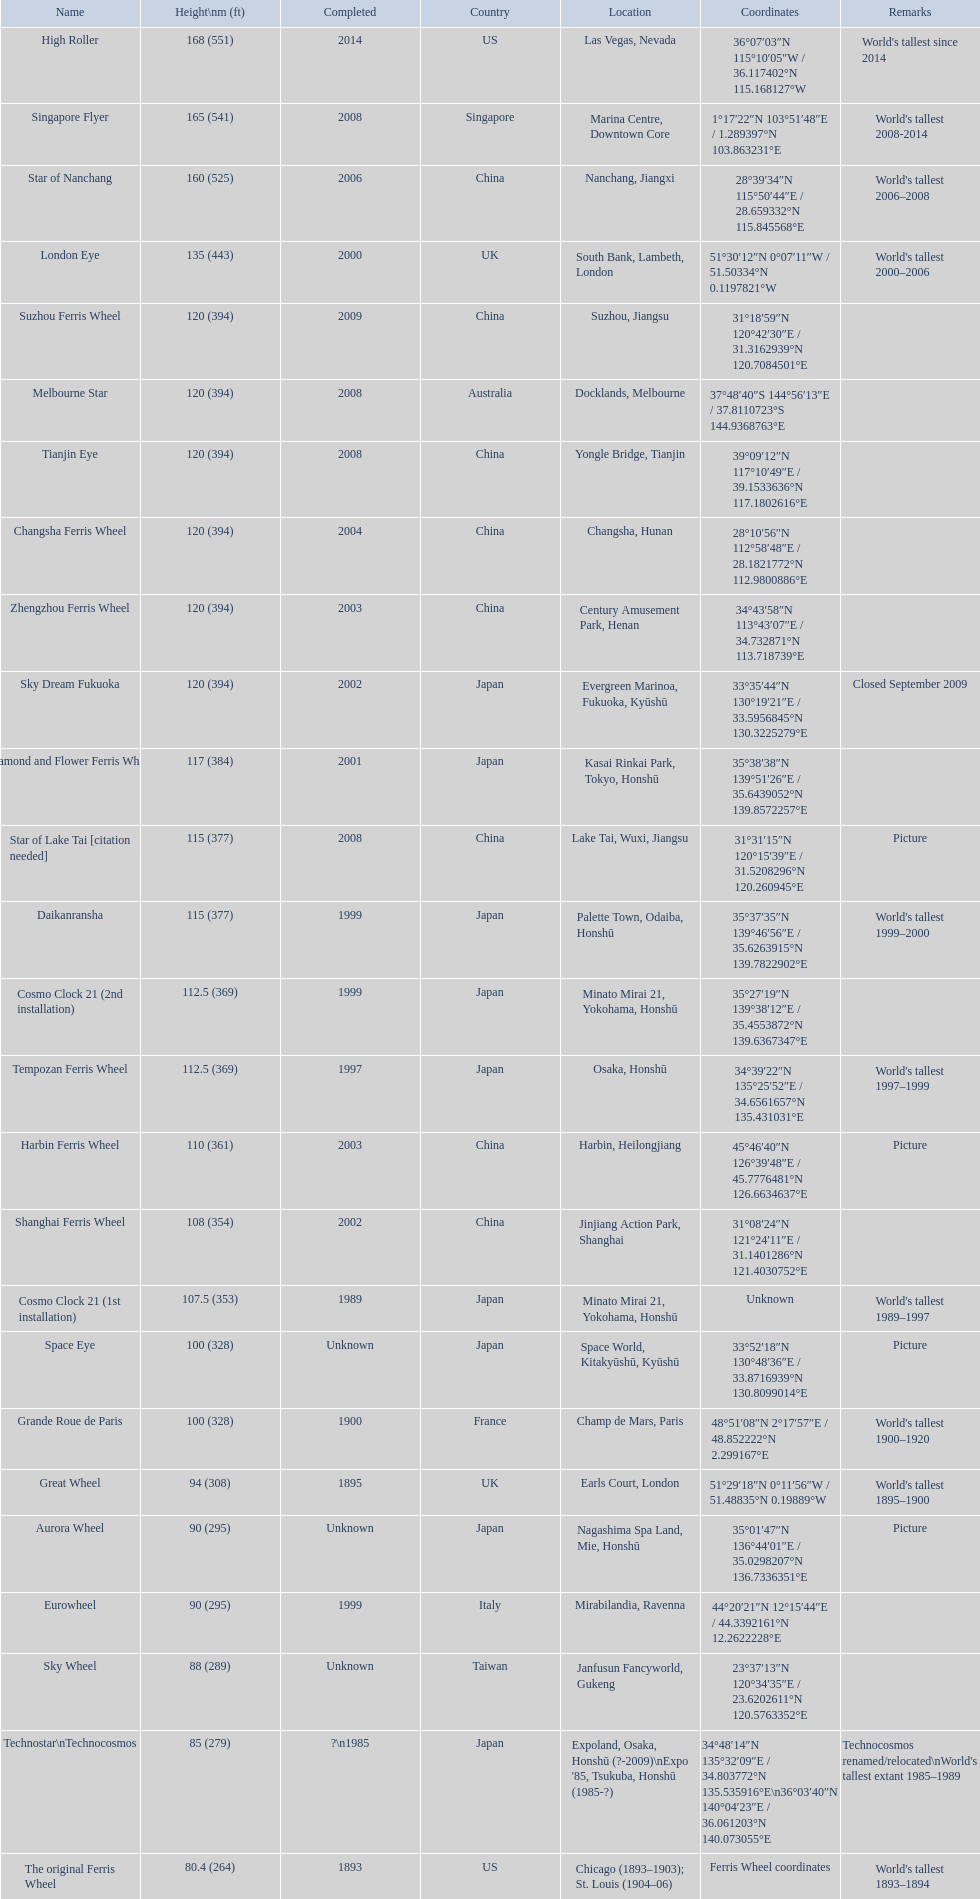What is the height of the star of nanchang roller coaster? 165 (541). When was the star of nanchang roller coaster finished? 2008. What is the title of the most ancient roller coaster? Star of Nanchang. 